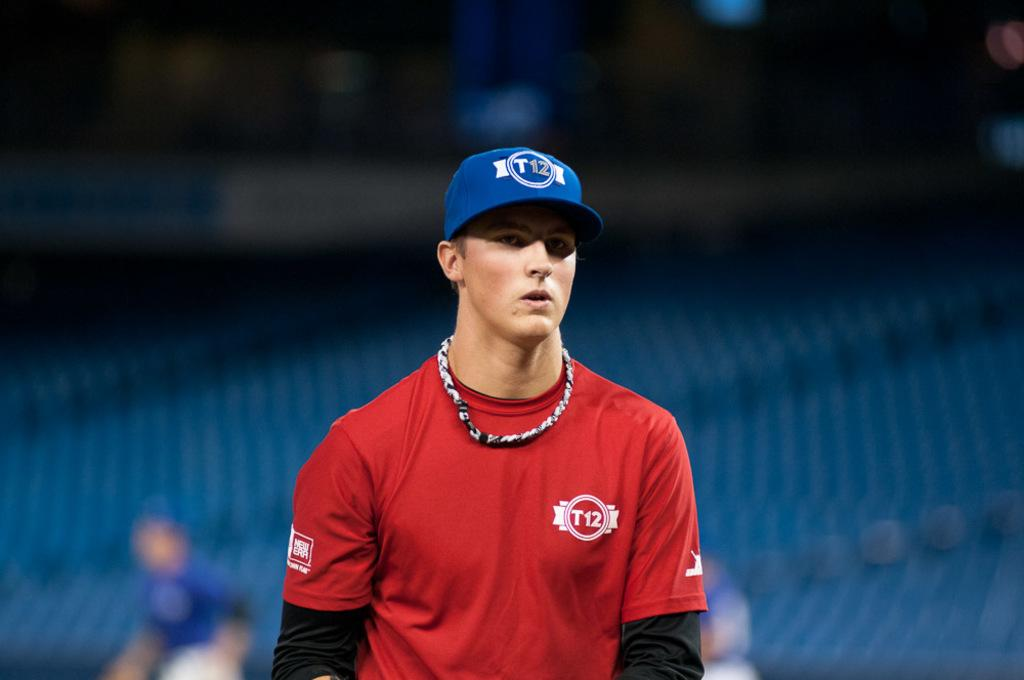<image>
Create a compact narrative representing the image presented. A young man wears a blue baseball hat with a red shirt and T12 in white letters on the upper left side of the shirt. 